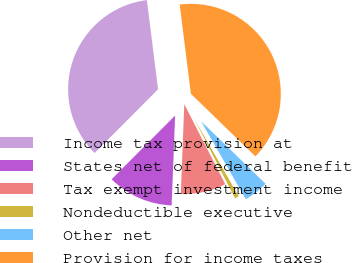Convert chart to OTSL. <chart><loc_0><loc_0><loc_500><loc_500><pie_chart><fcel>Income tax provision at<fcel>States net of federal benefit<fcel>Tax exempt investment income<fcel>Nondeductible executive<fcel>Other net<fcel>Provision for income taxes<nl><fcel>35.54%<fcel>11.85%<fcel>8.15%<fcel>0.75%<fcel>4.45%<fcel>39.24%<nl></chart> 